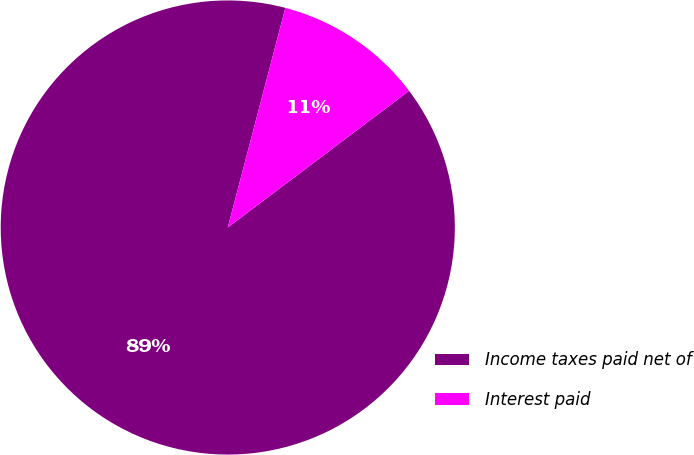<chart> <loc_0><loc_0><loc_500><loc_500><pie_chart><fcel>Income taxes paid net of<fcel>Interest paid<nl><fcel>89.36%<fcel>10.64%<nl></chart> 